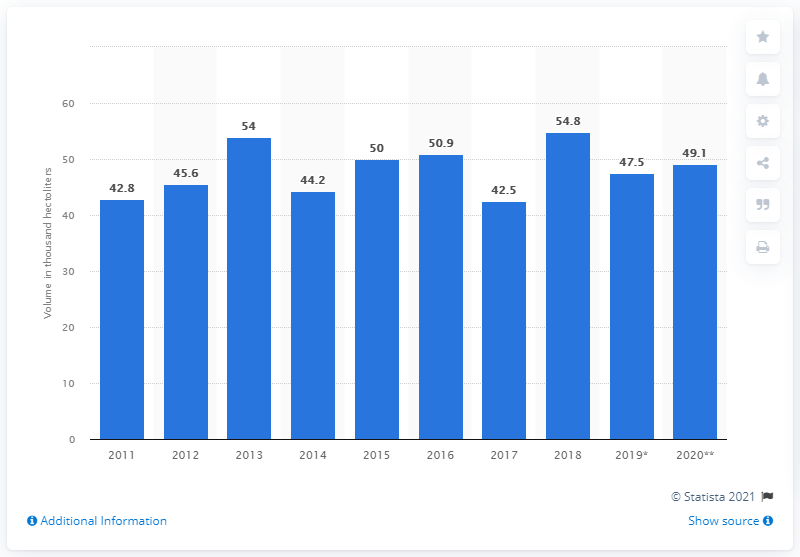List a handful of essential elements in this visual. In 2011, there was a fluctuation in wine exports. 